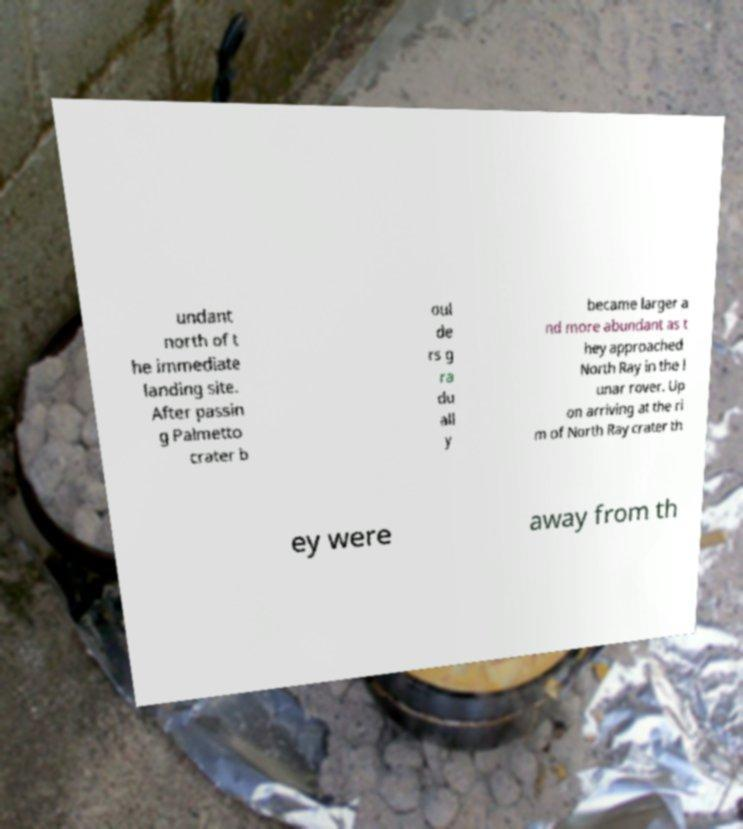Please read and relay the text visible in this image. What does it say? undant north of t he immediate landing site. After passin g Palmetto crater b oul de rs g ra du all y became larger a nd more abundant as t hey approached North Ray in the l unar rover. Up on arriving at the ri m of North Ray crater th ey were away from th 